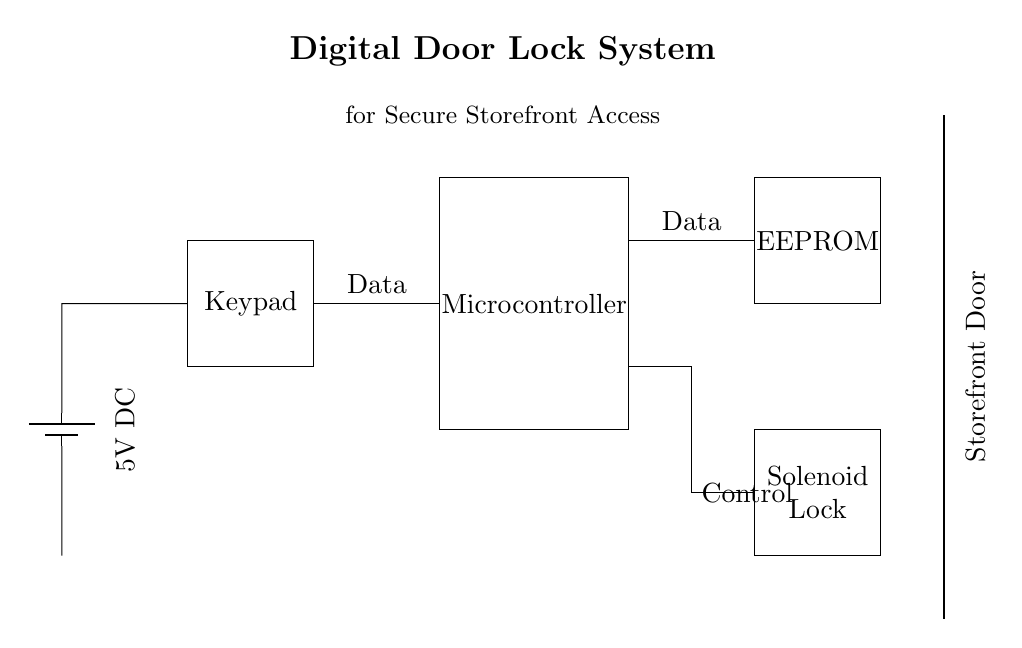What is the voltage of this circuit? The voltage is 5V, as indicated by the label next to the battery component in the circuit. It represents the power supply for the whole system.
Answer: 5V What components are used in this digital door lock system? The components include a battery, keypad, microcontroller, EEPROM, and solenoid lock. These are represented as distinct blocks in the diagram.
Answer: Battery, keypad, microcontroller, EEPROM, solenoid lock How is the keypad connected to the microcontroller? The keypad is connected to the microcontroller via a wire segment from the keypad output on the left side to the input on the microcontroller. This indicates data flow from the keypad to the controller.
Answer: Data wire What is the purpose of the EEPROM in the circuit? The EEPROM stores data related to user access or codes, which the microcontroller retrieves when needed. It is part of the system that maintains memory for locked access.
Answer: Storage of data What type of lock is used in this system? The system uses a solenoid lock, which is activated electronically to secure or release the door upon receiving a signal from the microcontroller based on keypad input.
Answer: Solenoid lock What connects the microcontroller to the solenoid lock? The connection is established through a control wire that runs from the microcontroller's output to the solenoid lock, indicating it can send commands to activate or deactivate locking.
Answer: Control wire How many main components are there in total? The main components are five in total: battery, keypad, microcontroller, EEPROM, and solenoid lock. Each serves a distinct function in the system.
Answer: Five components 